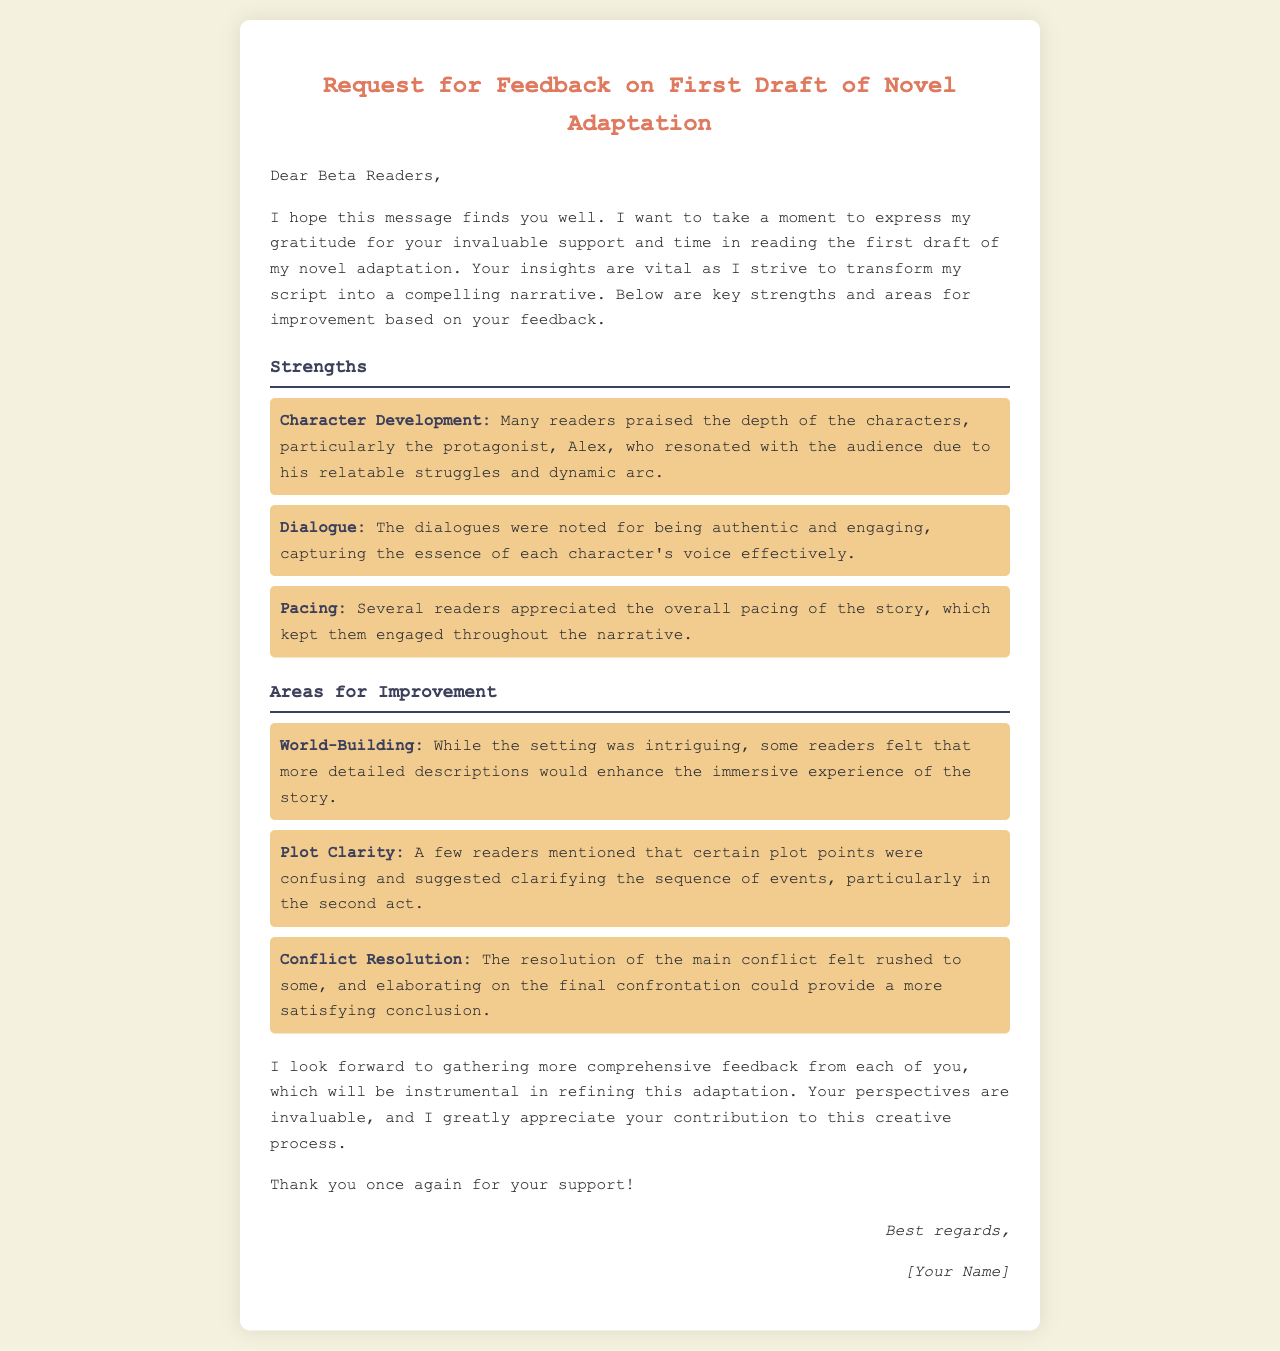What is the title of the document? The title is displayed prominently at the top of the document, indicating the subject matter.
Answer: Request for Feedback on First Draft of Novel Adaptation Who is the protagonist mentioned in the feedback? The protagonist is referred to specifically in the strengths section related to character development.
Answer: Alex What aspect of the story did several readers appreciate? Reader feedback in the strengths section highlights specific aspects of the narrative they enjoyed.
Answer: Pacing What area for improvement is related to the setting? This area is identified and detailed under the section for areas needing enhancement.
Answer: World-Building Which conflict resolution aspect feels rushed according to the feedback? The feedback specifically mentions a point regarding the conclusion of the main conflict.
Answer: Conflict Resolution What type of feedback does the sender hope to gather? The sender expresses what type of input they seek from the beta readers throughout the message.
Answer: Comprehensive feedback What color is used for the section title indicating strengths? The color choice for section titles is a notable design element that can be observed in the document's structure.
Answer: #3d405b Who signed off the document? The sign-off clearly indicates the author's name at the end of the document.
Answer: [Your Name] 